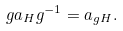Convert formula to latex. <formula><loc_0><loc_0><loc_500><loc_500>g a _ { H } g ^ { - 1 } = a _ { g H } .</formula> 